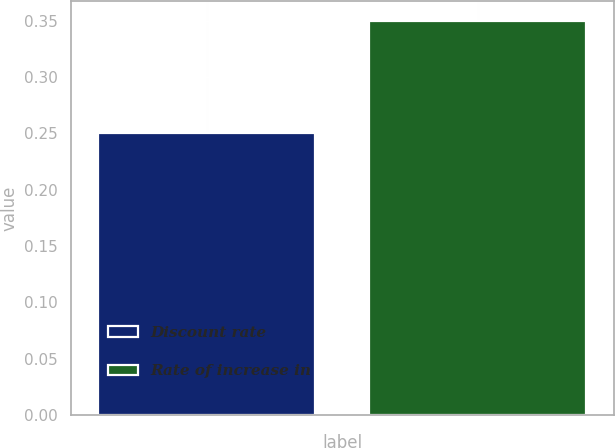Convert chart. <chart><loc_0><loc_0><loc_500><loc_500><bar_chart><fcel>Discount rate<fcel>Rate of increase in<nl><fcel>0.25<fcel>0.35<nl></chart> 